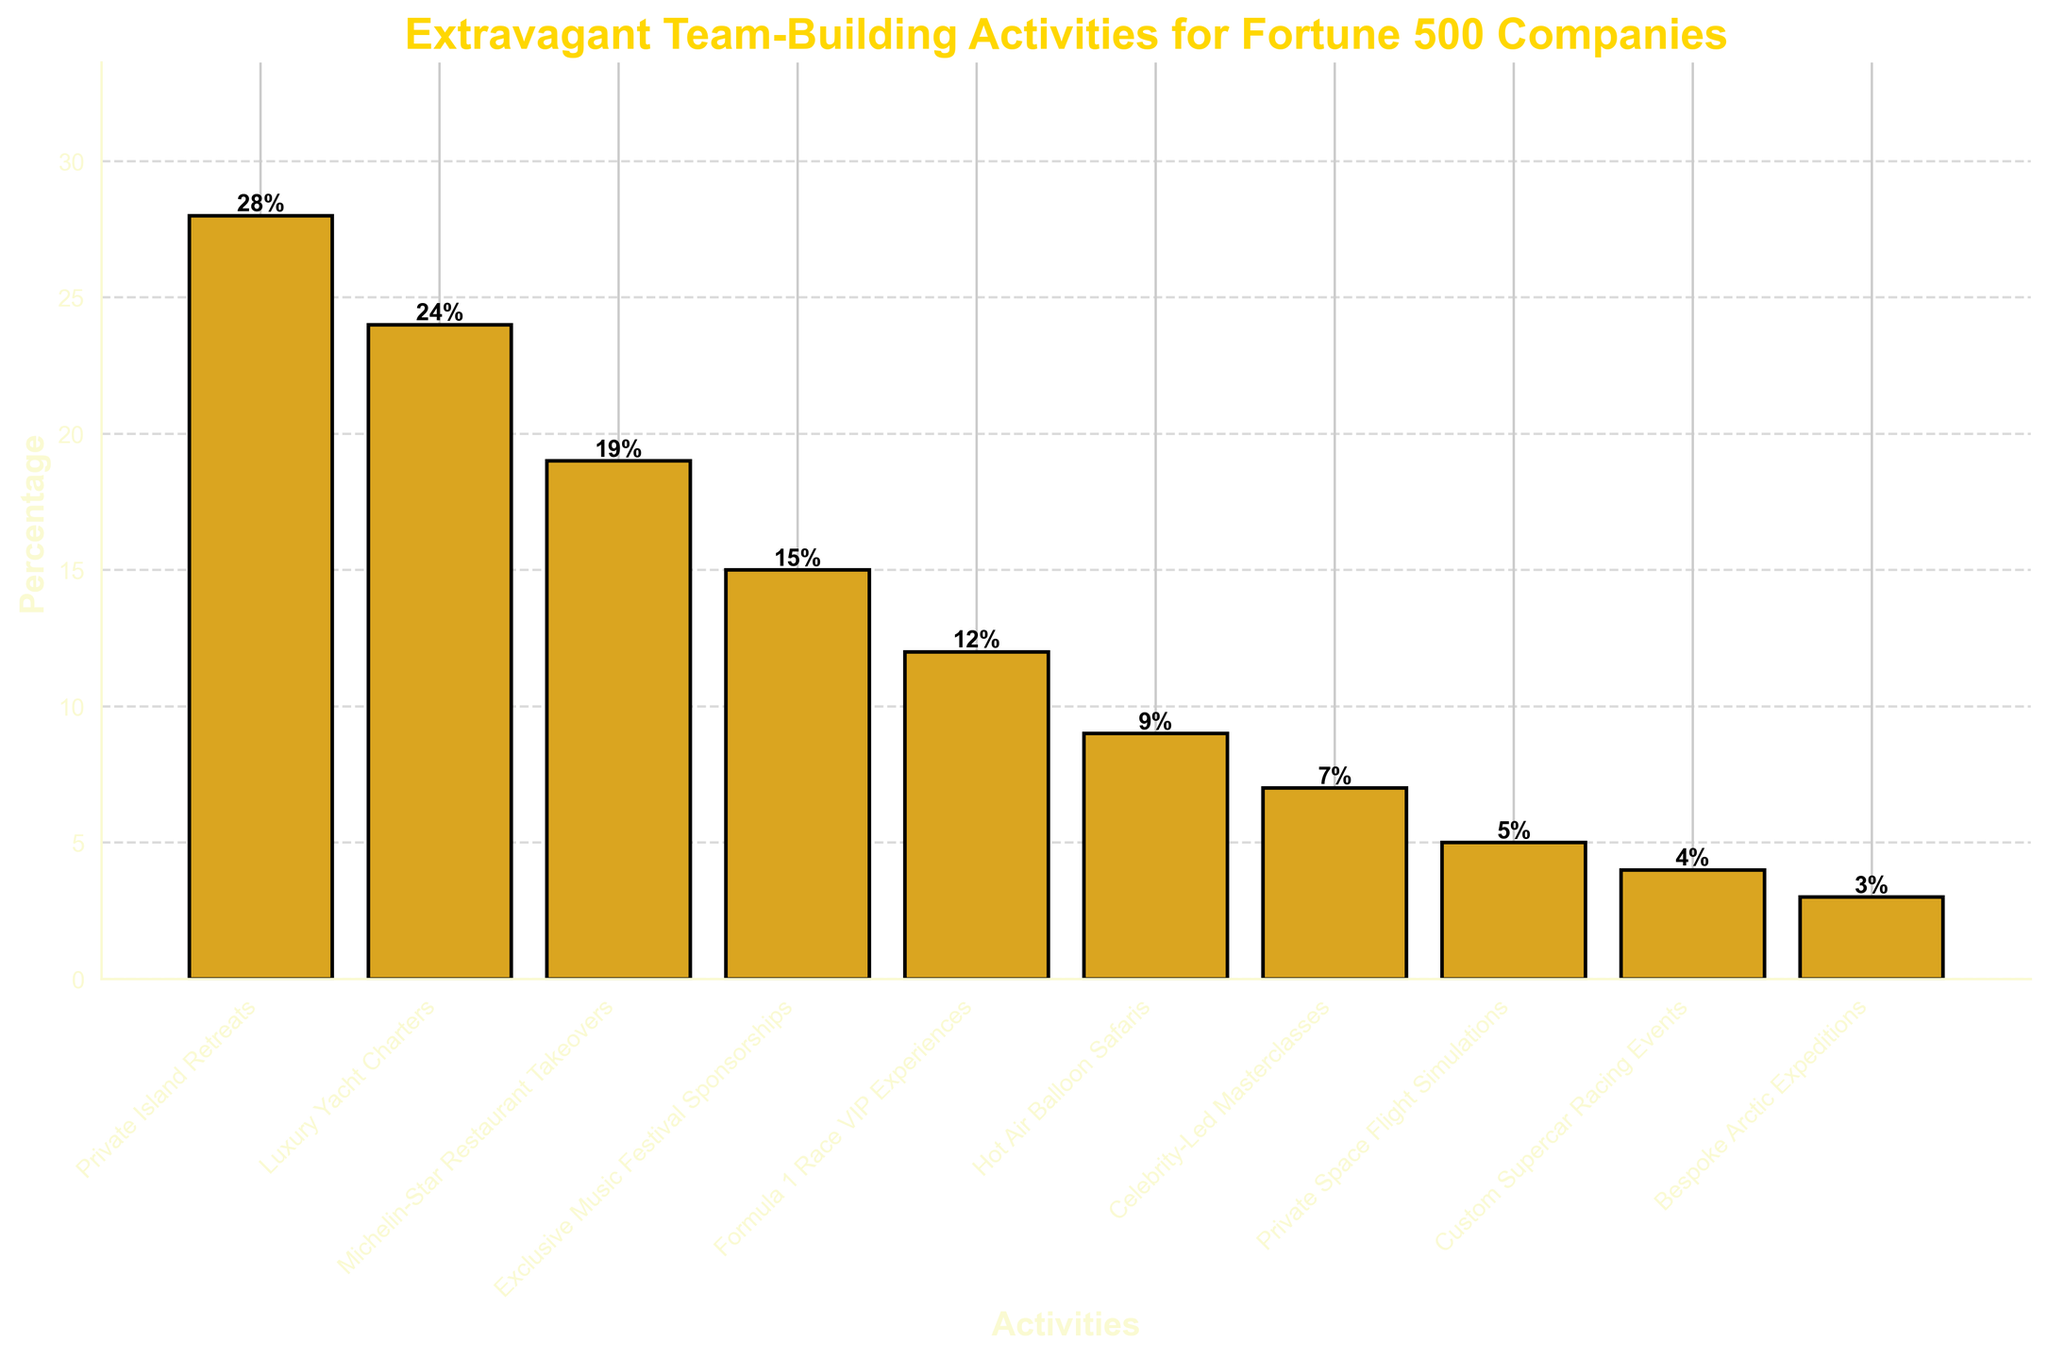Which activity is the most popular for team-building among Fortune 500 companies? Look for the tallest bar in the bar chart, which represents the highest percentage. The activity with the tallest bar is "Private Island Retreats" at 28%.
Answer: Private Island Retreats Which two activities are tied for the lowest popularity? Look for the bars with the smallest heights. The activities "Custom Supercar Racing Events" and "Bespoke Arctic Expeditions" have the lowest percentages at 4% and 3%, respectively.
Answer: Custom Supercar Racing Events and Bespoke Arctic Expeditions How much more popular are Private Island Retreats compared to Fourmula 1 Race VIP Experiences? Subtract the percentage of "Formula 1 Race VIP Experiences" (12%) from "Private Island Retreats" (28%). 28% - 12% = 16%.
Answer: 16% What is the combined percentage of the activities that involve a form of travel (Private Island Retreats, Luxury Yacht Charters, Hot Air Balloon Safaris, Bespoke Arctic Expeditions)? Sum the percentages of "Private Island Retreats" (28%), "Luxury Yacht Charters" (24%), "Hot Air Balloon Safaris" (9%), and "Bespoke Arctic Expeditions" (3%). 28% + 24% + 9% + 3% = 64%.
Answer: 64% Is the percentage of "Luxury Yacht Charters" higher than the combined percentage of "Celebrity-Led Masterclasses" and "Private Space Flight Simulations"? Compare the percentage of "Luxury Yacht Charters" (24%) with the sum of the percentages of "Celebrity-Led Masterclasses" (7%) and "Private Space Flight Simulations" (5%). 7% + 5% = 12%, which is less than 24%.
Answer: Yes Which activity has a percentage closest to the average percentage of all activities? First, find the average percentage by summing all percentages and dividing by the number of activities: (28% + 24% + 19% + 15% + 12% + 9% + 7% + 5% + 4% + 3%) / 10 = 12.6%. The activity closest to this average is "Formula 1 Race VIP Experiences" at 12%.
Answer: Formula 1 Race VIP Experiences What percentage of companies prefer activities related to food and music (Michelin-Star Restaurant Takeovers, Exclusive Music Festival Sponsorships)? Sum the percentages of "Michelin-Star Restaurant Takeovers" (19%) and "Exclusive Music Festival Sponsorships" (15%). 19% + 15% = 34%.
Answer: 34% How many activities have a percentage greater than 10%? Count the bars that have a percentage higher than 10%. These activities are "Private Island Retreats," "Luxury Yacht Charters," "Michelin-Star Restaurant Takeovers," "Exclusive Music Festival Sponsorships," and "Formula 1 Race VIP Experiences." There are 5 such activities.
Answer: 5 